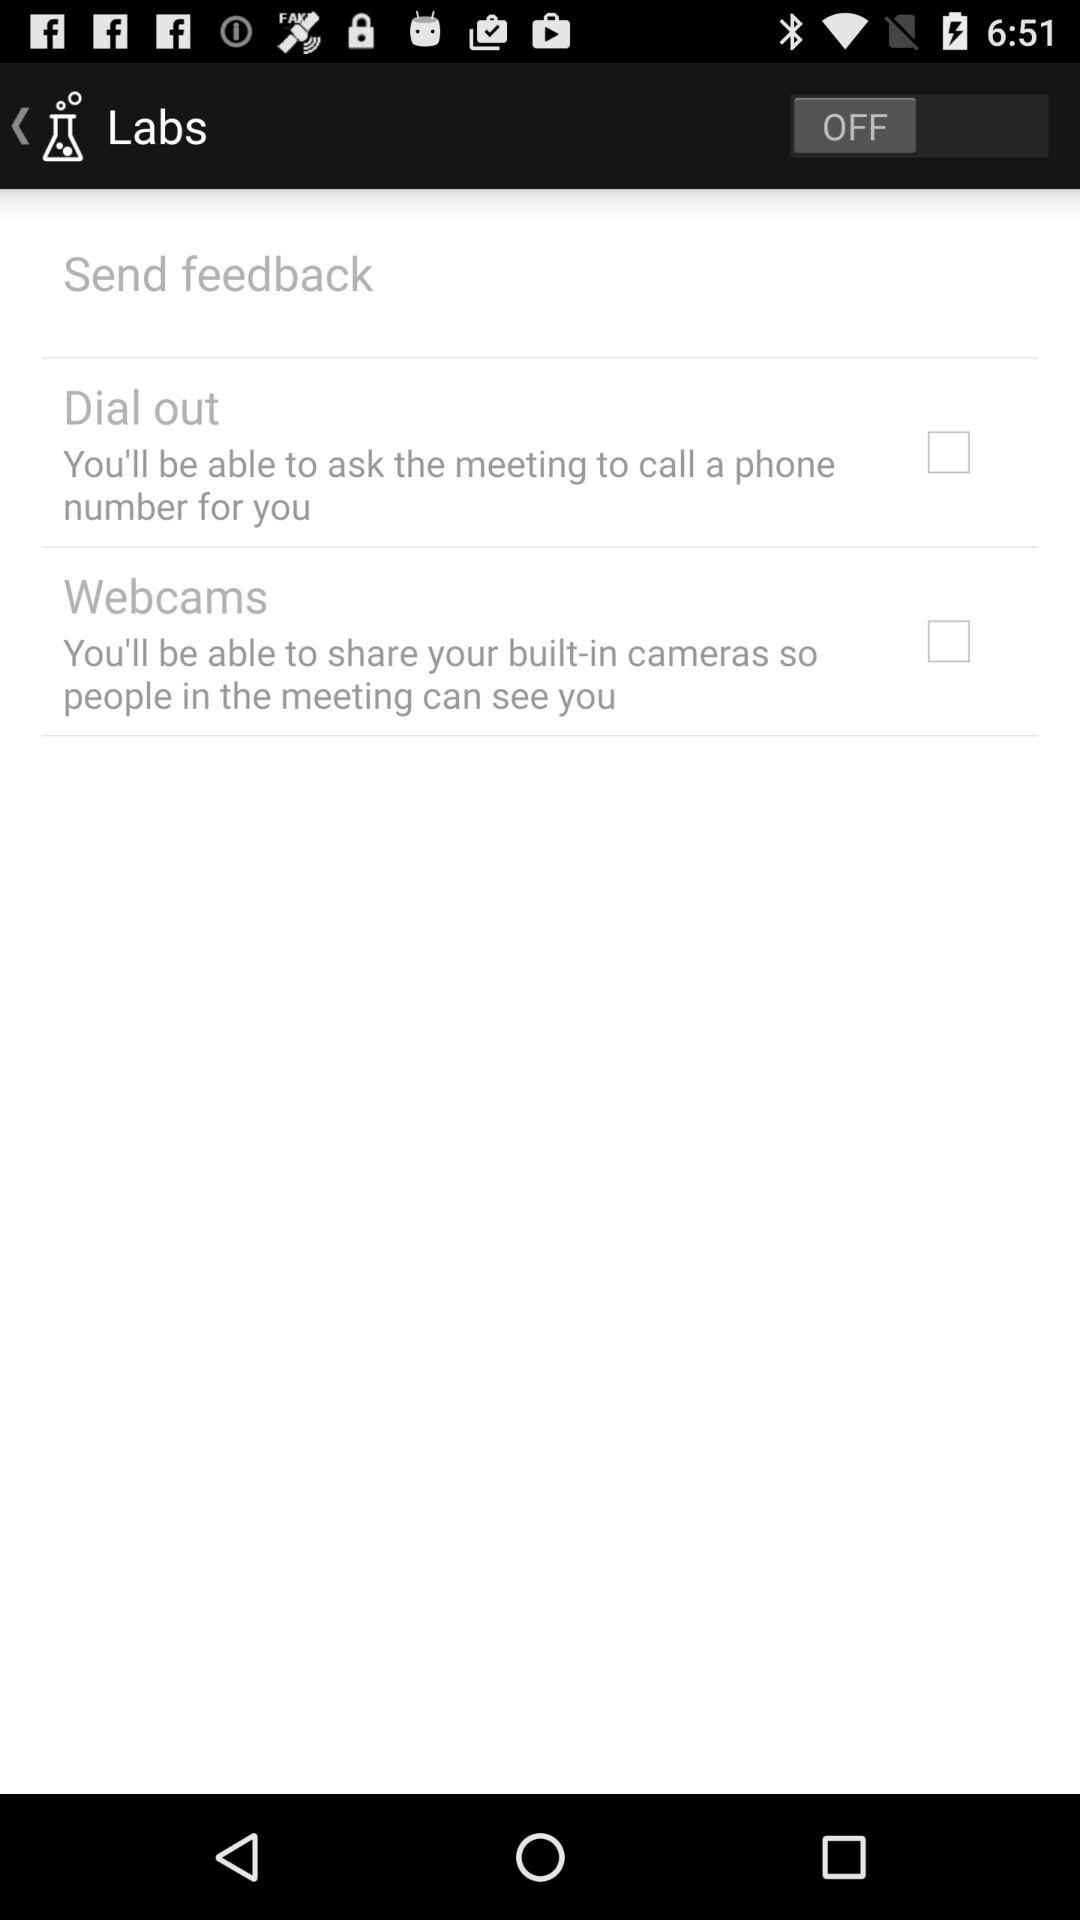What is the status of the "Dial out"? The status is "off". 